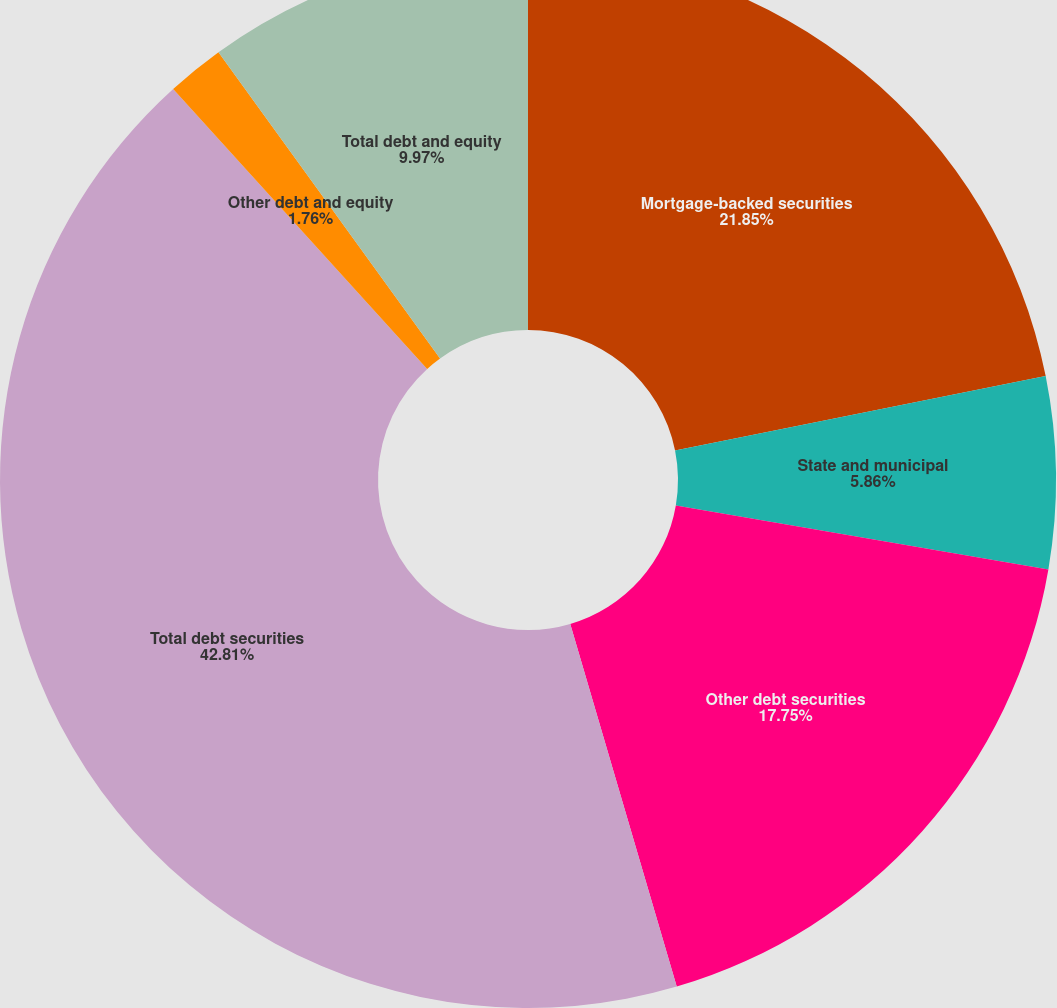Convert chart to OTSL. <chart><loc_0><loc_0><loc_500><loc_500><pie_chart><fcel>Mortgage-backed securities<fcel>State and municipal<fcel>Other debt securities<fcel>Total debt securities<fcel>Other debt and equity<fcel>Total debt and equity<nl><fcel>21.85%<fcel>5.86%<fcel>17.75%<fcel>42.82%<fcel>1.76%<fcel>9.97%<nl></chart> 